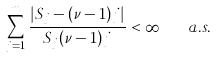Convert formula to latex. <formula><loc_0><loc_0><loc_500><loc_500>\sum _ { j = 1 } ^ { m } \frac { | S _ { j } - ( \nu - 1 ) j | } { S _ { j } ( \nu - 1 ) j } < \infty \quad a . s .</formula> 